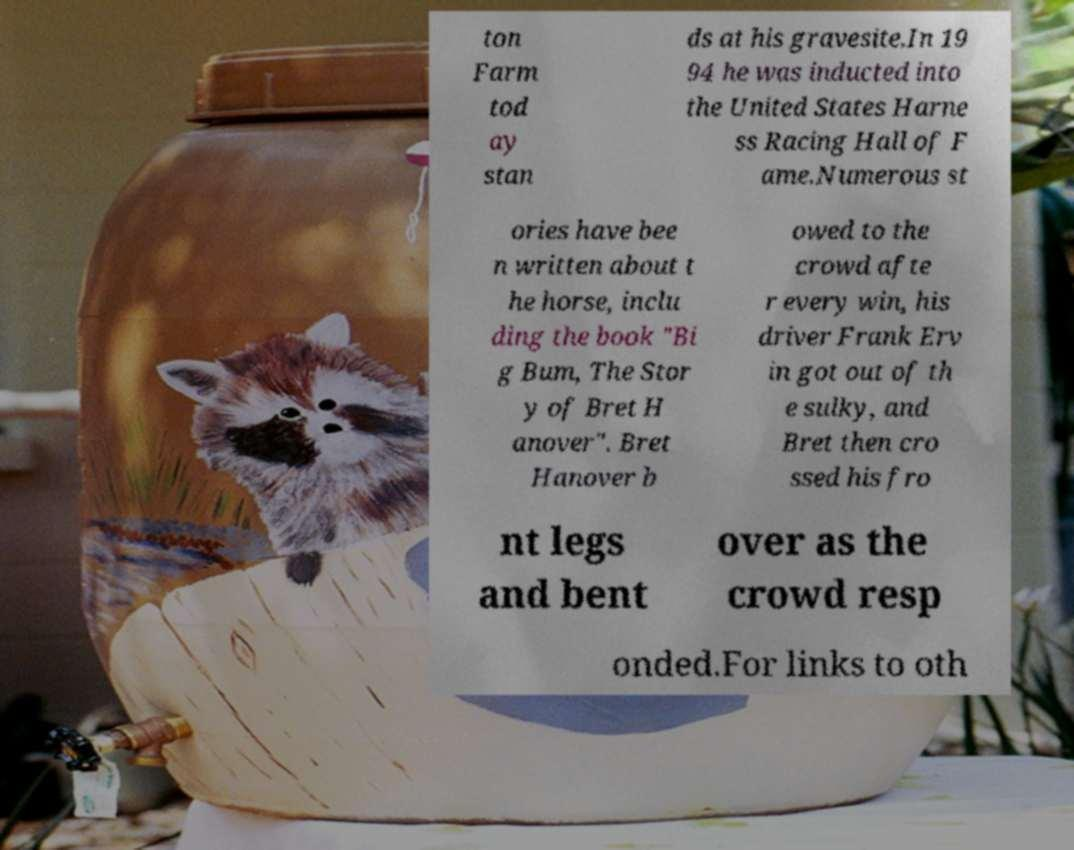There's text embedded in this image that I need extracted. Can you transcribe it verbatim? ton Farm tod ay stan ds at his gravesite.In 19 94 he was inducted into the United States Harne ss Racing Hall of F ame.Numerous st ories have bee n written about t he horse, inclu ding the book "Bi g Bum, The Stor y of Bret H anover". Bret Hanover b owed to the crowd afte r every win, his driver Frank Erv in got out of th e sulky, and Bret then cro ssed his fro nt legs and bent over as the crowd resp onded.For links to oth 